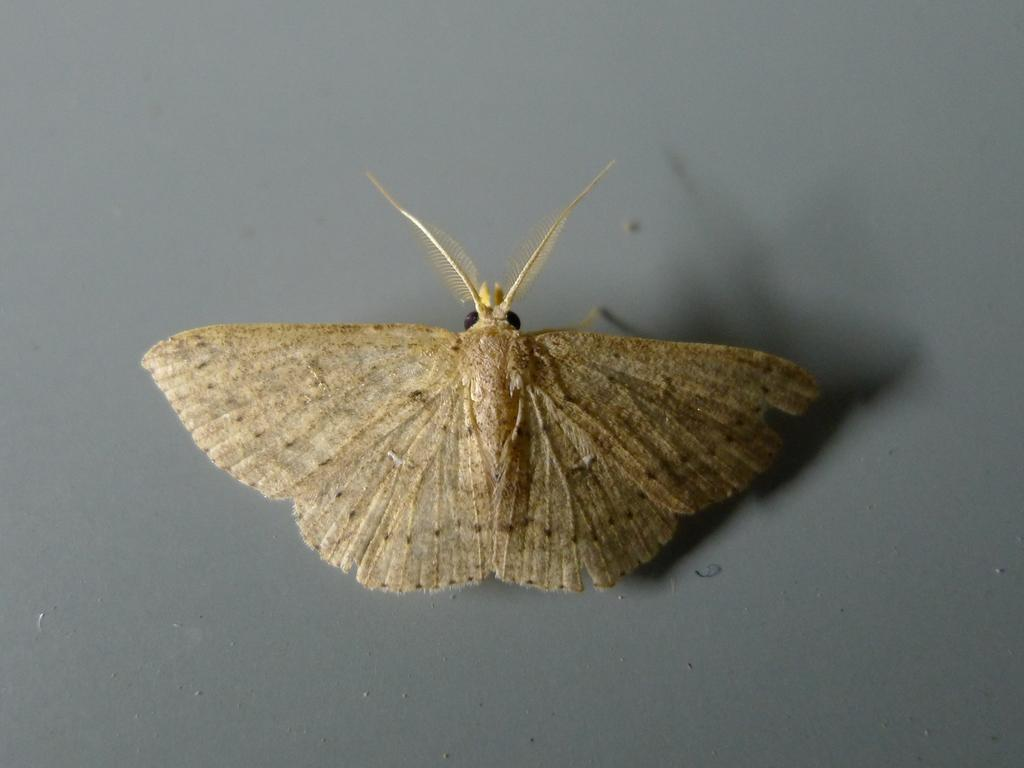What is the main subject of the image? There is a butterfly in the image. Where is the butterfly located in the image? The butterfly is in the center of the image. What is the butterfly resting on in the image? The butterfly is on the surface in the image. What type of glass is the butterfly using to write its name in the image? There is no glass or writing present in the image; it features a butterfly resting on a surface. 